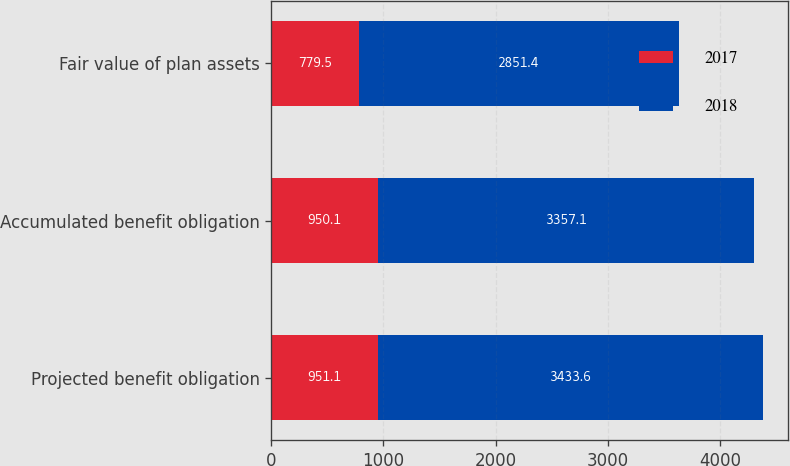Convert chart. <chart><loc_0><loc_0><loc_500><loc_500><stacked_bar_chart><ecel><fcel>Projected benefit obligation<fcel>Accumulated benefit obligation<fcel>Fair value of plan assets<nl><fcel>2017<fcel>951.1<fcel>950.1<fcel>779.5<nl><fcel>2018<fcel>3433.6<fcel>3357.1<fcel>2851.4<nl></chart> 